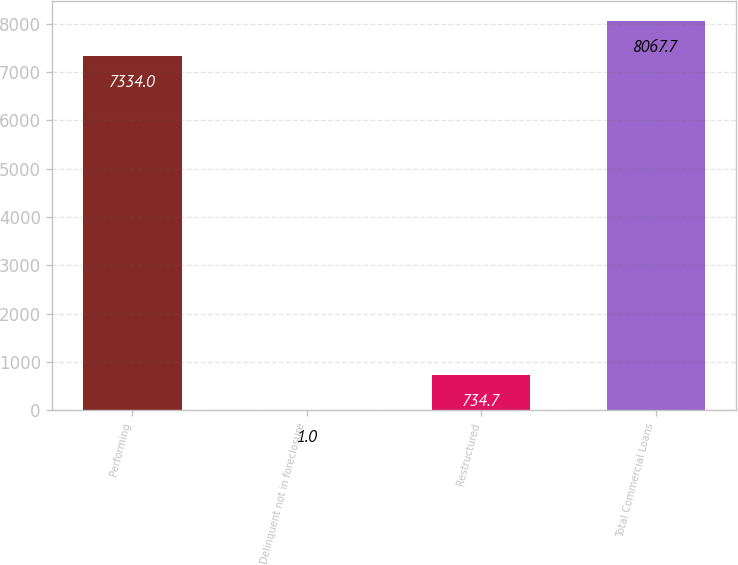Convert chart to OTSL. <chart><loc_0><loc_0><loc_500><loc_500><bar_chart><fcel>Performing<fcel>Delinquent not in foreclosure<fcel>Restructured<fcel>Total Commercial Loans<nl><fcel>7334<fcel>1<fcel>734.7<fcel>8067.7<nl></chart> 